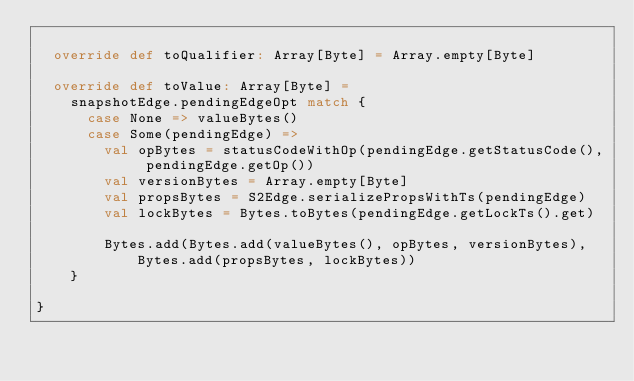Convert code to text. <code><loc_0><loc_0><loc_500><loc_500><_Scala_>
  override def toQualifier: Array[Byte] = Array.empty[Byte]

  override def toValue: Array[Byte] =
    snapshotEdge.pendingEdgeOpt match {
      case None => valueBytes()
      case Some(pendingEdge) =>
        val opBytes = statusCodeWithOp(pendingEdge.getStatusCode(), pendingEdge.getOp())
        val versionBytes = Array.empty[Byte]
        val propsBytes = S2Edge.serializePropsWithTs(pendingEdge)
        val lockBytes = Bytes.toBytes(pendingEdge.getLockTs().get)

        Bytes.add(Bytes.add(valueBytes(), opBytes, versionBytes), Bytes.add(propsBytes, lockBytes))
    }

}
</code> 